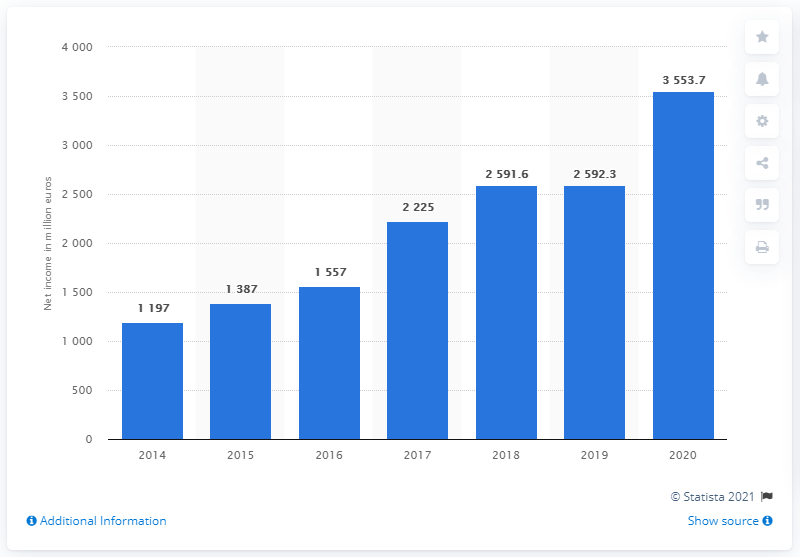Mention a couple of crucial points in this snapshot. In 2020, ASML's net income was 3,553.7 million euros. 